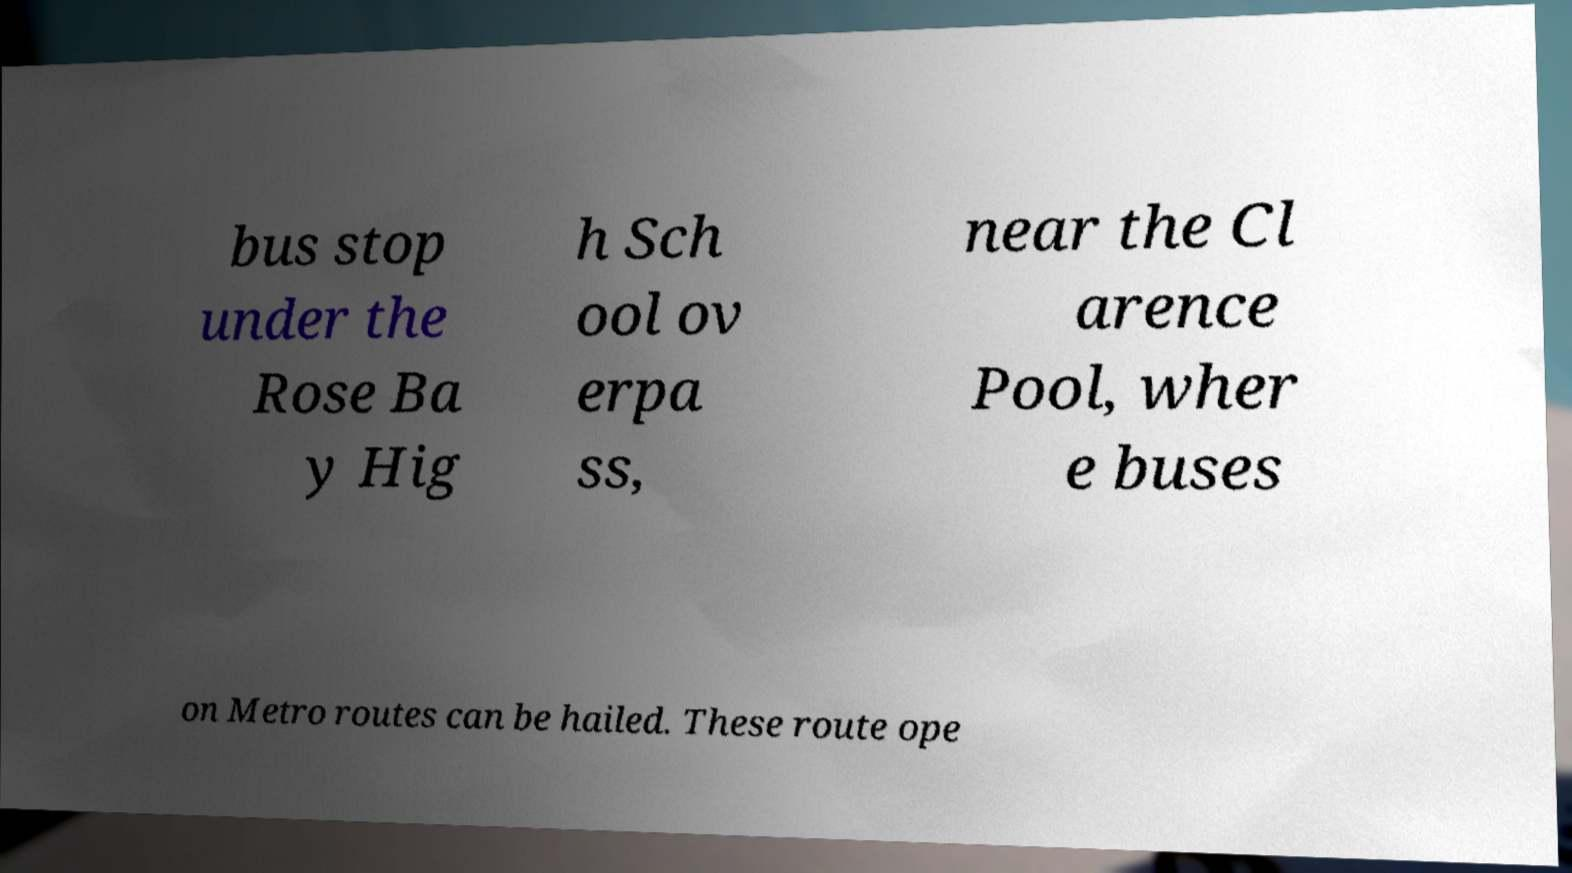Please identify and transcribe the text found in this image. bus stop under the Rose Ba y Hig h Sch ool ov erpa ss, near the Cl arence Pool, wher e buses on Metro routes can be hailed. These route ope 